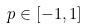<formula> <loc_0><loc_0><loc_500><loc_500>p \in [ - 1 , 1 ]</formula> 